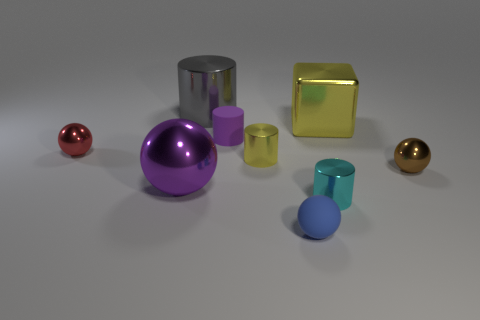Subtract all big cylinders. How many cylinders are left? 3 Subtract all cylinders. How many objects are left? 5 Subtract all gray cylinders. How many cylinders are left? 3 Subtract all blue cylinders. Subtract all red blocks. How many cylinders are left? 4 Subtract all small rubber cylinders. Subtract all big red matte spheres. How many objects are left? 8 Add 2 purple rubber cylinders. How many purple rubber cylinders are left? 3 Add 4 tiny green matte cubes. How many tiny green matte cubes exist? 4 Subtract 1 red balls. How many objects are left? 8 